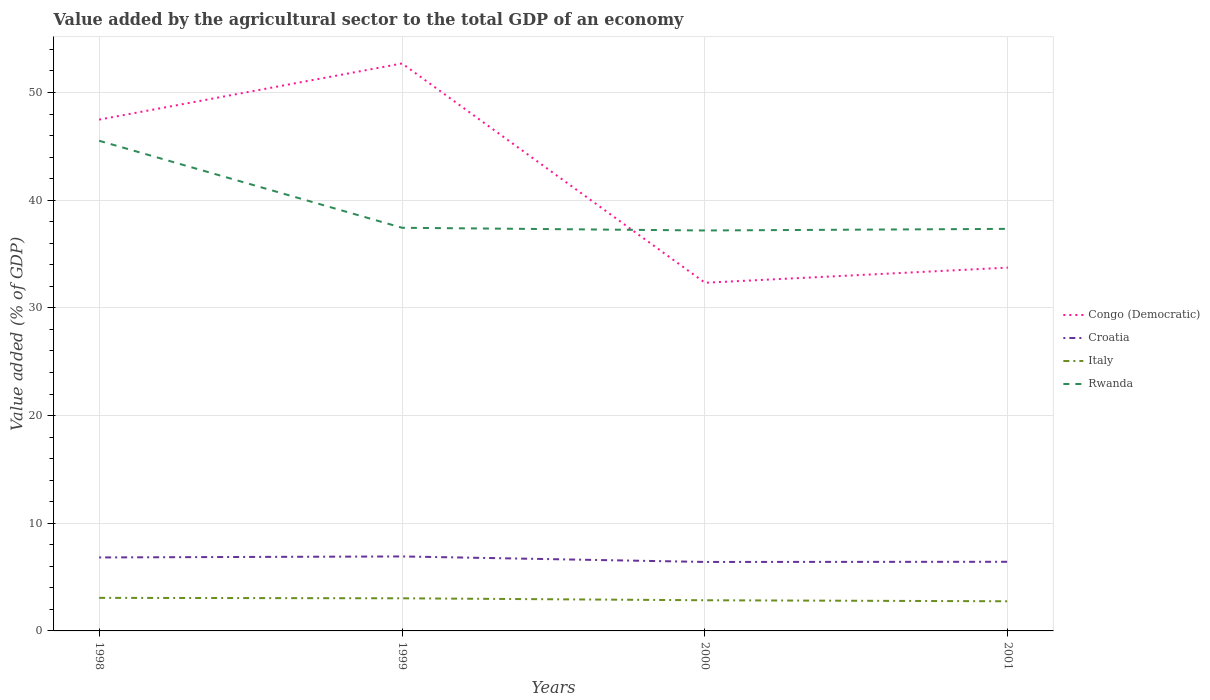How many different coloured lines are there?
Offer a terse response. 4. Does the line corresponding to Rwanda intersect with the line corresponding to Italy?
Provide a short and direct response. No. Is the number of lines equal to the number of legend labels?
Keep it short and to the point. Yes. Across all years, what is the maximum value added by the agricultural sector to the total GDP in Croatia?
Keep it short and to the point. 6.41. What is the total value added by the agricultural sector to the total GDP in Congo (Democratic) in the graph?
Your response must be concise. 15.15. What is the difference between the highest and the second highest value added by the agricultural sector to the total GDP in Rwanda?
Your answer should be compact. 8.33. What is the difference between the highest and the lowest value added by the agricultural sector to the total GDP in Italy?
Offer a very short reply. 2. Is the value added by the agricultural sector to the total GDP in Croatia strictly greater than the value added by the agricultural sector to the total GDP in Congo (Democratic) over the years?
Provide a succinct answer. Yes. How many lines are there?
Provide a succinct answer. 4. How many years are there in the graph?
Your answer should be compact. 4. What is the difference between two consecutive major ticks on the Y-axis?
Provide a short and direct response. 10. Are the values on the major ticks of Y-axis written in scientific E-notation?
Keep it short and to the point. No. Does the graph contain any zero values?
Keep it short and to the point. No. Does the graph contain grids?
Keep it short and to the point. Yes. What is the title of the graph?
Make the answer very short. Value added by the agricultural sector to the total GDP of an economy. Does "Bulgaria" appear as one of the legend labels in the graph?
Offer a terse response. No. What is the label or title of the X-axis?
Keep it short and to the point. Years. What is the label or title of the Y-axis?
Offer a very short reply. Value added (% of GDP). What is the Value added (% of GDP) in Congo (Democratic) in 1998?
Provide a short and direct response. 47.48. What is the Value added (% of GDP) in Croatia in 1998?
Ensure brevity in your answer.  6.82. What is the Value added (% of GDP) in Italy in 1998?
Ensure brevity in your answer.  3.07. What is the Value added (% of GDP) of Rwanda in 1998?
Offer a terse response. 45.52. What is the Value added (% of GDP) in Congo (Democratic) in 1999?
Provide a short and direct response. 52.7. What is the Value added (% of GDP) in Croatia in 1999?
Provide a short and direct response. 6.92. What is the Value added (% of GDP) in Italy in 1999?
Your response must be concise. 3.03. What is the Value added (% of GDP) in Rwanda in 1999?
Provide a succinct answer. 37.44. What is the Value added (% of GDP) of Congo (Democratic) in 2000?
Provide a short and direct response. 32.33. What is the Value added (% of GDP) in Croatia in 2000?
Offer a very short reply. 6.41. What is the Value added (% of GDP) in Italy in 2000?
Provide a succinct answer. 2.85. What is the Value added (% of GDP) in Rwanda in 2000?
Provide a short and direct response. 37.19. What is the Value added (% of GDP) in Congo (Democratic) in 2001?
Provide a short and direct response. 33.74. What is the Value added (% of GDP) of Croatia in 2001?
Make the answer very short. 6.42. What is the Value added (% of GDP) in Italy in 2001?
Your answer should be very brief. 2.75. What is the Value added (% of GDP) of Rwanda in 2001?
Provide a short and direct response. 37.34. Across all years, what is the maximum Value added (% of GDP) in Congo (Democratic)?
Provide a succinct answer. 52.7. Across all years, what is the maximum Value added (% of GDP) in Croatia?
Offer a very short reply. 6.92. Across all years, what is the maximum Value added (% of GDP) in Italy?
Your response must be concise. 3.07. Across all years, what is the maximum Value added (% of GDP) in Rwanda?
Make the answer very short. 45.52. Across all years, what is the minimum Value added (% of GDP) of Congo (Democratic)?
Provide a short and direct response. 32.33. Across all years, what is the minimum Value added (% of GDP) of Croatia?
Ensure brevity in your answer.  6.41. Across all years, what is the minimum Value added (% of GDP) in Italy?
Offer a terse response. 2.75. Across all years, what is the minimum Value added (% of GDP) in Rwanda?
Keep it short and to the point. 37.19. What is the total Value added (% of GDP) in Congo (Democratic) in the graph?
Ensure brevity in your answer.  166.25. What is the total Value added (% of GDP) in Croatia in the graph?
Make the answer very short. 26.57. What is the total Value added (% of GDP) of Italy in the graph?
Your response must be concise. 11.7. What is the total Value added (% of GDP) in Rwanda in the graph?
Your response must be concise. 157.48. What is the difference between the Value added (% of GDP) of Congo (Democratic) in 1998 and that in 1999?
Give a very brief answer. -5.21. What is the difference between the Value added (% of GDP) in Croatia in 1998 and that in 1999?
Keep it short and to the point. -0.09. What is the difference between the Value added (% of GDP) of Italy in 1998 and that in 1999?
Ensure brevity in your answer.  0.04. What is the difference between the Value added (% of GDP) of Rwanda in 1998 and that in 1999?
Offer a terse response. 8.08. What is the difference between the Value added (% of GDP) in Congo (Democratic) in 1998 and that in 2000?
Give a very brief answer. 15.15. What is the difference between the Value added (% of GDP) in Croatia in 1998 and that in 2000?
Ensure brevity in your answer.  0.42. What is the difference between the Value added (% of GDP) of Italy in 1998 and that in 2000?
Your answer should be very brief. 0.22. What is the difference between the Value added (% of GDP) in Rwanda in 1998 and that in 2000?
Your response must be concise. 8.33. What is the difference between the Value added (% of GDP) in Congo (Democratic) in 1998 and that in 2001?
Ensure brevity in your answer.  13.74. What is the difference between the Value added (% of GDP) of Croatia in 1998 and that in 2001?
Ensure brevity in your answer.  0.4. What is the difference between the Value added (% of GDP) of Italy in 1998 and that in 2001?
Provide a succinct answer. 0.32. What is the difference between the Value added (% of GDP) of Rwanda in 1998 and that in 2001?
Offer a terse response. 8.18. What is the difference between the Value added (% of GDP) of Congo (Democratic) in 1999 and that in 2000?
Your answer should be compact. 20.36. What is the difference between the Value added (% of GDP) of Croatia in 1999 and that in 2000?
Provide a succinct answer. 0.51. What is the difference between the Value added (% of GDP) in Italy in 1999 and that in 2000?
Offer a very short reply. 0.18. What is the difference between the Value added (% of GDP) of Rwanda in 1999 and that in 2000?
Offer a terse response. 0.25. What is the difference between the Value added (% of GDP) of Congo (Democratic) in 1999 and that in 2001?
Ensure brevity in your answer.  18.96. What is the difference between the Value added (% of GDP) of Croatia in 1999 and that in 2001?
Keep it short and to the point. 0.5. What is the difference between the Value added (% of GDP) of Italy in 1999 and that in 2001?
Keep it short and to the point. 0.28. What is the difference between the Value added (% of GDP) of Rwanda in 1999 and that in 2001?
Your response must be concise. 0.1. What is the difference between the Value added (% of GDP) in Congo (Democratic) in 2000 and that in 2001?
Provide a short and direct response. -1.41. What is the difference between the Value added (% of GDP) in Croatia in 2000 and that in 2001?
Your answer should be compact. -0.01. What is the difference between the Value added (% of GDP) of Italy in 2000 and that in 2001?
Your answer should be compact. 0.1. What is the difference between the Value added (% of GDP) in Rwanda in 2000 and that in 2001?
Your answer should be very brief. -0.15. What is the difference between the Value added (% of GDP) in Congo (Democratic) in 1998 and the Value added (% of GDP) in Croatia in 1999?
Your response must be concise. 40.57. What is the difference between the Value added (% of GDP) of Congo (Democratic) in 1998 and the Value added (% of GDP) of Italy in 1999?
Make the answer very short. 44.45. What is the difference between the Value added (% of GDP) in Congo (Democratic) in 1998 and the Value added (% of GDP) in Rwanda in 1999?
Your answer should be very brief. 10.04. What is the difference between the Value added (% of GDP) in Croatia in 1998 and the Value added (% of GDP) in Italy in 1999?
Provide a short and direct response. 3.79. What is the difference between the Value added (% of GDP) in Croatia in 1998 and the Value added (% of GDP) in Rwanda in 1999?
Provide a short and direct response. -30.61. What is the difference between the Value added (% of GDP) in Italy in 1998 and the Value added (% of GDP) in Rwanda in 1999?
Offer a very short reply. -34.37. What is the difference between the Value added (% of GDP) of Congo (Democratic) in 1998 and the Value added (% of GDP) of Croatia in 2000?
Your response must be concise. 41.08. What is the difference between the Value added (% of GDP) of Congo (Democratic) in 1998 and the Value added (% of GDP) of Italy in 2000?
Your answer should be compact. 44.63. What is the difference between the Value added (% of GDP) in Congo (Democratic) in 1998 and the Value added (% of GDP) in Rwanda in 2000?
Provide a short and direct response. 10.3. What is the difference between the Value added (% of GDP) in Croatia in 1998 and the Value added (% of GDP) in Italy in 2000?
Offer a very short reply. 3.98. What is the difference between the Value added (% of GDP) in Croatia in 1998 and the Value added (% of GDP) in Rwanda in 2000?
Ensure brevity in your answer.  -30.36. What is the difference between the Value added (% of GDP) in Italy in 1998 and the Value added (% of GDP) in Rwanda in 2000?
Your answer should be very brief. -34.12. What is the difference between the Value added (% of GDP) in Congo (Democratic) in 1998 and the Value added (% of GDP) in Croatia in 2001?
Give a very brief answer. 41.06. What is the difference between the Value added (% of GDP) in Congo (Democratic) in 1998 and the Value added (% of GDP) in Italy in 2001?
Your answer should be compact. 44.73. What is the difference between the Value added (% of GDP) in Congo (Democratic) in 1998 and the Value added (% of GDP) in Rwanda in 2001?
Your response must be concise. 10.15. What is the difference between the Value added (% of GDP) in Croatia in 1998 and the Value added (% of GDP) in Italy in 2001?
Your response must be concise. 4.07. What is the difference between the Value added (% of GDP) in Croatia in 1998 and the Value added (% of GDP) in Rwanda in 2001?
Your answer should be very brief. -30.51. What is the difference between the Value added (% of GDP) in Italy in 1998 and the Value added (% of GDP) in Rwanda in 2001?
Ensure brevity in your answer.  -34.27. What is the difference between the Value added (% of GDP) in Congo (Democratic) in 1999 and the Value added (% of GDP) in Croatia in 2000?
Your answer should be very brief. 46.29. What is the difference between the Value added (% of GDP) in Congo (Democratic) in 1999 and the Value added (% of GDP) in Italy in 2000?
Provide a succinct answer. 49.85. What is the difference between the Value added (% of GDP) of Congo (Democratic) in 1999 and the Value added (% of GDP) of Rwanda in 2000?
Offer a very short reply. 15.51. What is the difference between the Value added (% of GDP) of Croatia in 1999 and the Value added (% of GDP) of Italy in 2000?
Your response must be concise. 4.07. What is the difference between the Value added (% of GDP) of Croatia in 1999 and the Value added (% of GDP) of Rwanda in 2000?
Offer a terse response. -30.27. What is the difference between the Value added (% of GDP) of Italy in 1999 and the Value added (% of GDP) of Rwanda in 2000?
Provide a succinct answer. -34.16. What is the difference between the Value added (% of GDP) of Congo (Democratic) in 1999 and the Value added (% of GDP) of Croatia in 2001?
Keep it short and to the point. 46.28. What is the difference between the Value added (% of GDP) in Congo (Democratic) in 1999 and the Value added (% of GDP) in Italy in 2001?
Provide a succinct answer. 49.94. What is the difference between the Value added (% of GDP) of Congo (Democratic) in 1999 and the Value added (% of GDP) of Rwanda in 2001?
Make the answer very short. 15.36. What is the difference between the Value added (% of GDP) in Croatia in 1999 and the Value added (% of GDP) in Italy in 2001?
Make the answer very short. 4.16. What is the difference between the Value added (% of GDP) in Croatia in 1999 and the Value added (% of GDP) in Rwanda in 2001?
Provide a succinct answer. -30.42. What is the difference between the Value added (% of GDP) in Italy in 1999 and the Value added (% of GDP) in Rwanda in 2001?
Provide a succinct answer. -34.31. What is the difference between the Value added (% of GDP) in Congo (Democratic) in 2000 and the Value added (% of GDP) in Croatia in 2001?
Ensure brevity in your answer.  25.91. What is the difference between the Value added (% of GDP) of Congo (Democratic) in 2000 and the Value added (% of GDP) of Italy in 2001?
Offer a very short reply. 29.58. What is the difference between the Value added (% of GDP) of Congo (Democratic) in 2000 and the Value added (% of GDP) of Rwanda in 2001?
Provide a succinct answer. -5.01. What is the difference between the Value added (% of GDP) of Croatia in 2000 and the Value added (% of GDP) of Italy in 2001?
Keep it short and to the point. 3.65. What is the difference between the Value added (% of GDP) of Croatia in 2000 and the Value added (% of GDP) of Rwanda in 2001?
Provide a succinct answer. -30.93. What is the difference between the Value added (% of GDP) in Italy in 2000 and the Value added (% of GDP) in Rwanda in 2001?
Provide a succinct answer. -34.49. What is the average Value added (% of GDP) in Congo (Democratic) per year?
Provide a succinct answer. 41.56. What is the average Value added (% of GDP) in Croatia per year?
Your response must be concise. 6.64. What is the average Value added (% of GDP) of Italy per year?
Make the answer very short. 2.93. What is the average Value added (% of GDP) in Rwanda per year?
Ensure brevity in your answer.  39.37. In the year 1998, what is the difference between the Value added (% of GDP) in Congo (Democratic) and Value added (% of GDP) in Croatia?
Ensure brevity in your answer.  40.66. In the year 1998, what is the difference between the Value added (% of GDP) in Congo (Democratic) and Value added (% of GDP) in Italy?
Keep it short and to the point. 44.41. In the year 1998, what is the difference between the Value added (% of GDP) of Congo (Democratic) and Value added (% of GDP) of Rwanda?
Ensure brevity in your answer.  1.96. In the year 1998, what is the difference between the Value added (% of GDP) in Croatia and Value added (% of GDP) in Italy?
Offer a very short reply. 3.75. In the year 1998, what is the difference between the Value added (% of GDP) in Croatia and Value added (% of GDP) in Rwanda?
Provide a succinct answer. -38.69. In the year 1998, what is the difference between the Value added (% of GDP) in Italy and Value added (% of GDP) in Rwanda?
Offer a very short reply. -42.45. In the year 1999, what is the difference between the Value added (% of GDP) in Congo (Democratic) and Value added (% of GDP) in Croatia?
Your answer should be very brief. 45.78. In the year 1999, what is the difference between the Value added (% of GDP) of Congo (Democratic) and Value added (% of GDP) of Italy?
Give a very brief answer. 49.67. In the year 1999, what is the difference between the Value added (% of GDP) in Congo (Democratic) and Value added (% of GDP) in Rwanda?
Provide a succinct answer. 15.26. In the year 1999, what is the difference between the Value added (% of GDP) in Croatia and Value added (% of GDP) in Italy?
Keep it short and to the point. 3.89. In the year 1999, what is the difference between the Value added (% of GDP) in Croatia and Value added (% of GDP) in Rwanda?
Offer a terse response. -30.52. In the year 1999, what is the difference between the Value added (% of GDP) of Italy and Value added (% of GDP) of Rwanda?
Offer a terse response. -34.41. In the year 2000, what is the difference between the Value added (% of GDP) of Congo (Democratic) and Value added (% of GDP) of Croatia?
Offer a terse response. 25.93. In the year 2000, what is the difference between the Value added (% of GDP) of Congo (Democratic) and Value added (% of GDP) of Italy?
Offer a very short reply. 29.48. In the year 2000, what is the difference between the Value added (% of GDP) of Congo (Democratic) and Value added (% of GDP) of Rwanda?
Offer a very short reply. -4.86. In the year 2000, what is the difference between the Value added (% of GDP) in Croatia and Value added (% of GDP) in Italy?
Provide a succinct answer. 3.56. In the year 2000, what is the difference between the Value added (% of GDP) in Croatia and Value added (% of GDP) in Rwanda?
Offer a very short reply. -30.78. In the year 2000, what is the difference between the Value added (% of GDP) in Italy and Value added (% of GDP) in Rwanda?
Your answer should be compact. -34.34. In the year 2001, what is the difference between the Value added (% of GDP) of Congo (Democratic) and Value added (% of GDP) of Croatia?
Provide a short and direct response. 27.32. In the year 2001, what is the difference between the Value added (% of GDP) in Congo (Democratic) and Value added (% of GDP) in Italy?
Make the answer very short. 30.98. In the year 2001, what is the difference between the Value added (% of GDP) of Congo (Democratic) and Value added (% of GDP) of Rwanda?
Give a very brief answer. -3.6. In the year 2001, what is the difference between the Value added (% of GDP) of Croatia and Value added (% of GDP) of Italy?
Keep it short and to the point. 3.67. In the year 2001, what is the difference between the Value added (% of GDP) in Croatia and Value added (% of GDP) in Rwanda?
Give a very brief answer. -30.92. In the year 2001, what is the difference between the Value added (% of GDP) of Italy and Value added (% of GDP) of Rwanda?
Provide a succinct answer. -34.58. What is the ratio of the Value added (% of GDP) in Congo (Democratic) in 1998 to that in 1999?
Keep it short and to the point. 0.9. What is the ratio of the Value added (% of GDP) in Croatia in 1998 to that in 1999?
Give a very brief answer. 0.99. What is the ratio of the Value added (% of GDP) of Italy in 1998 to that in 1999?
Offer a very short reply. 1.01. What is the ratio of the Value added (% of GDP) of Rwanda in 1998 to that in 1999?
Give a very brief answer. 1.22. What is the ratio of the Value added (% of GDP) of Congo (Democratic) in 1998 to that in 2000?
Your response must be concise. 1.47. What is the ratio of the Value added (% of GDP) of Croatia in 1998 to that in 2000?
Provide a short and direct response. 1.07. What is the ratio of the Value added (% of GDP) in Italy in 1998 to that in 2000?
Your answer should be compact. 1.08. What is the ratio of the Value added (% of GDP) in Rwanda in 1998 to that in 2000?
Make the answer very short. 1.22. What is the ratio of the Value added (% of GDP) of Congo (Democratic) in 1998 to that in 2001?
Your response must be concise. 1.41. What is the ratio of the Value added (% of GDP) of Croatia in 1998 to that in 2001?
Give a very brief answer. 1.06. What is the ratio of the Value added (% of GDP) of Italy in 1998 to that in 2001?
Your response must be concise. 1.12. What is the ratio of the Value added (% of GDP) of Rwanda in 1998 to that in 2001?
Make the answer very short. 1.22. What is the ratio of the Value added (% of GDP) in Congo (Democratic) in 1999 to that in 2000?
Ensure brevity in your answer.  1.63. What is the ratio of the Value added (% of GDP) of Croatia in 1999 to that in 2000?
Provide a short and direct response. 1.08. What is the ratio of the Value added (% of GDP) in Italy in 1999 to that in 2000?
Your answer should be very brief. 1.06. What is the ratio of the Value added (% of GDP) of Congo (Democratic) in 1999 to that in 2001?
Make the answer very short. 1.56. What is the ratio of the Value added (% of GDP) in Croatia in 1999 to that in 2001?
Keep it short and to the point. 1.08. What is the ratio of the Value added (% of GDP) of Italy in 1999 to that in 2001?
Make the answer very short. 1.1. What is the ratio of the Value added (% of GDP) of Congo (Democratic) in 2000 to that in 2001?
Provide a short and direct response. 0.96. What is the ratio of the Value added (% of GDP) of Italy in 2000 to that in 2001?
Keep it short and to the point. 1.03. What is the ratio of the Value added (% of GDP) in Rwanda in 2000 to that in 2001?
Give a very brief answer. 1. What is the difference between the highest and the second highest Value added (% of GDP) of Congo (Democratic)?
Provide a succinct answer. 5.21. What is the difference between the highest and the second highest Value added (% of GDP) of Croatia?
Make the answer very short. 0.09. What is the difference between the highest and the second highest Value added (% of GDP) in Italy?
Offer a terse response. 0.04. What is the difference between the highest and the second highest Value added (% of GDP) of Rwanda?
Your answer should be very brief. 8.08. What is the difference between the highest and the lowest Value added (% of GDP) in Congo (Democratic)?
Keep it short and to the point. 20.36. What is the difference between the highest and the lowest Value added (% of GDP) of Croatia?
Ensure brevity in your answer.  0.51. What is the difference between the highest and the lowest Value added (% of GDP) in Italy?
Offer a very short reply. 0.32. What is the difference between the highest and the lowest Value added (% of GDP) in Rwanda?
Make the answer very short. 8.33. 